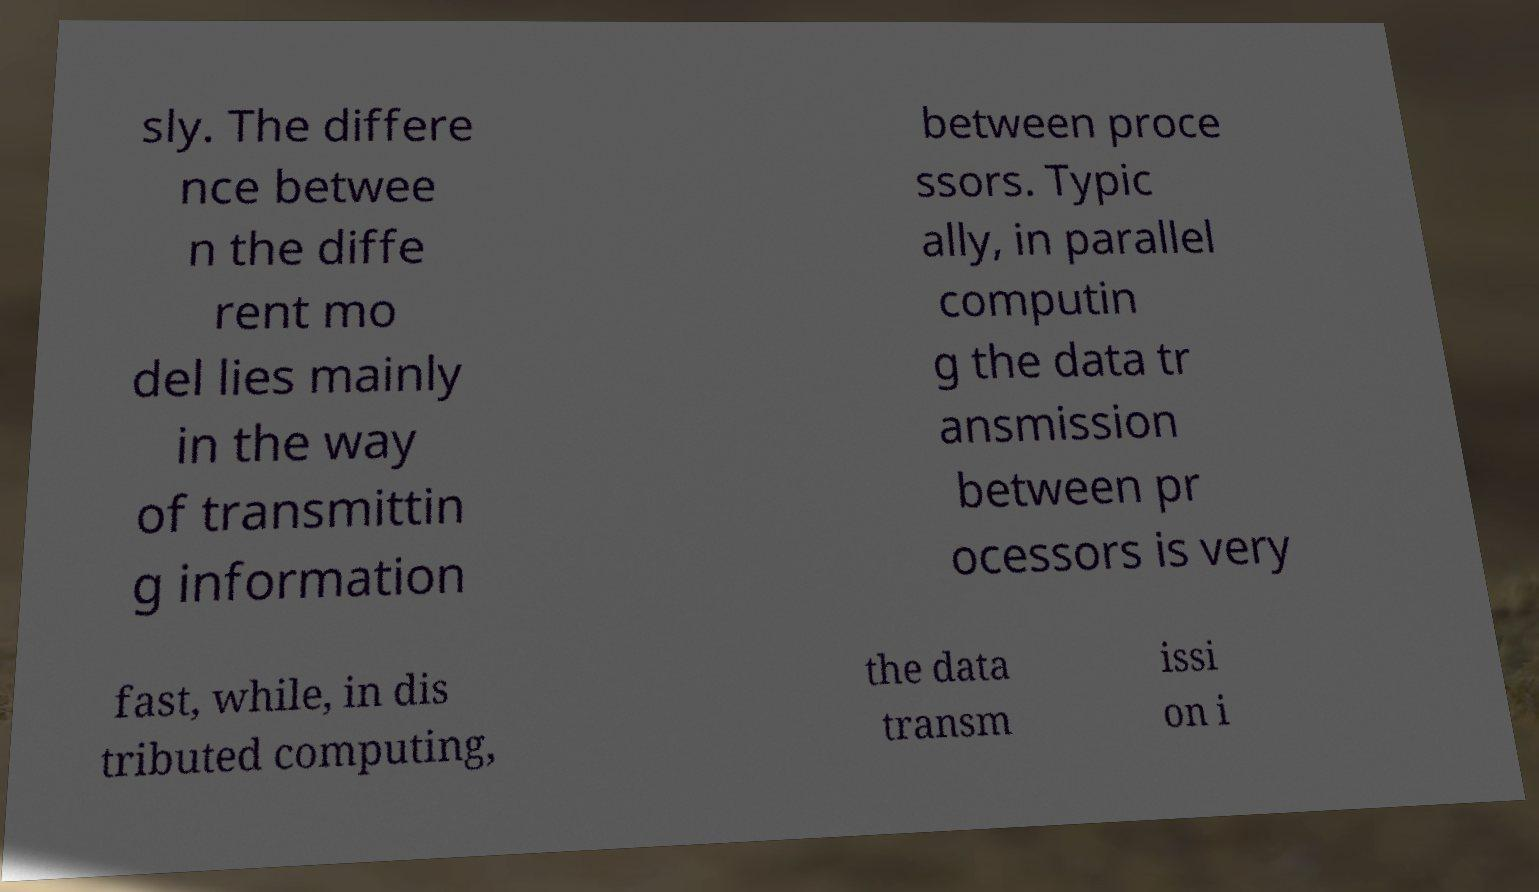Please identify and transcribe the text found in this image. sly. The differe nce betwee n the diffe rent mo del lies mainly in the way of transmittin g information between proce ssors. Typic ally, in parallel computin g the data tr ansmission between pr ocessors is very fast, while, in dis tributed computing, the data transm issi on i 